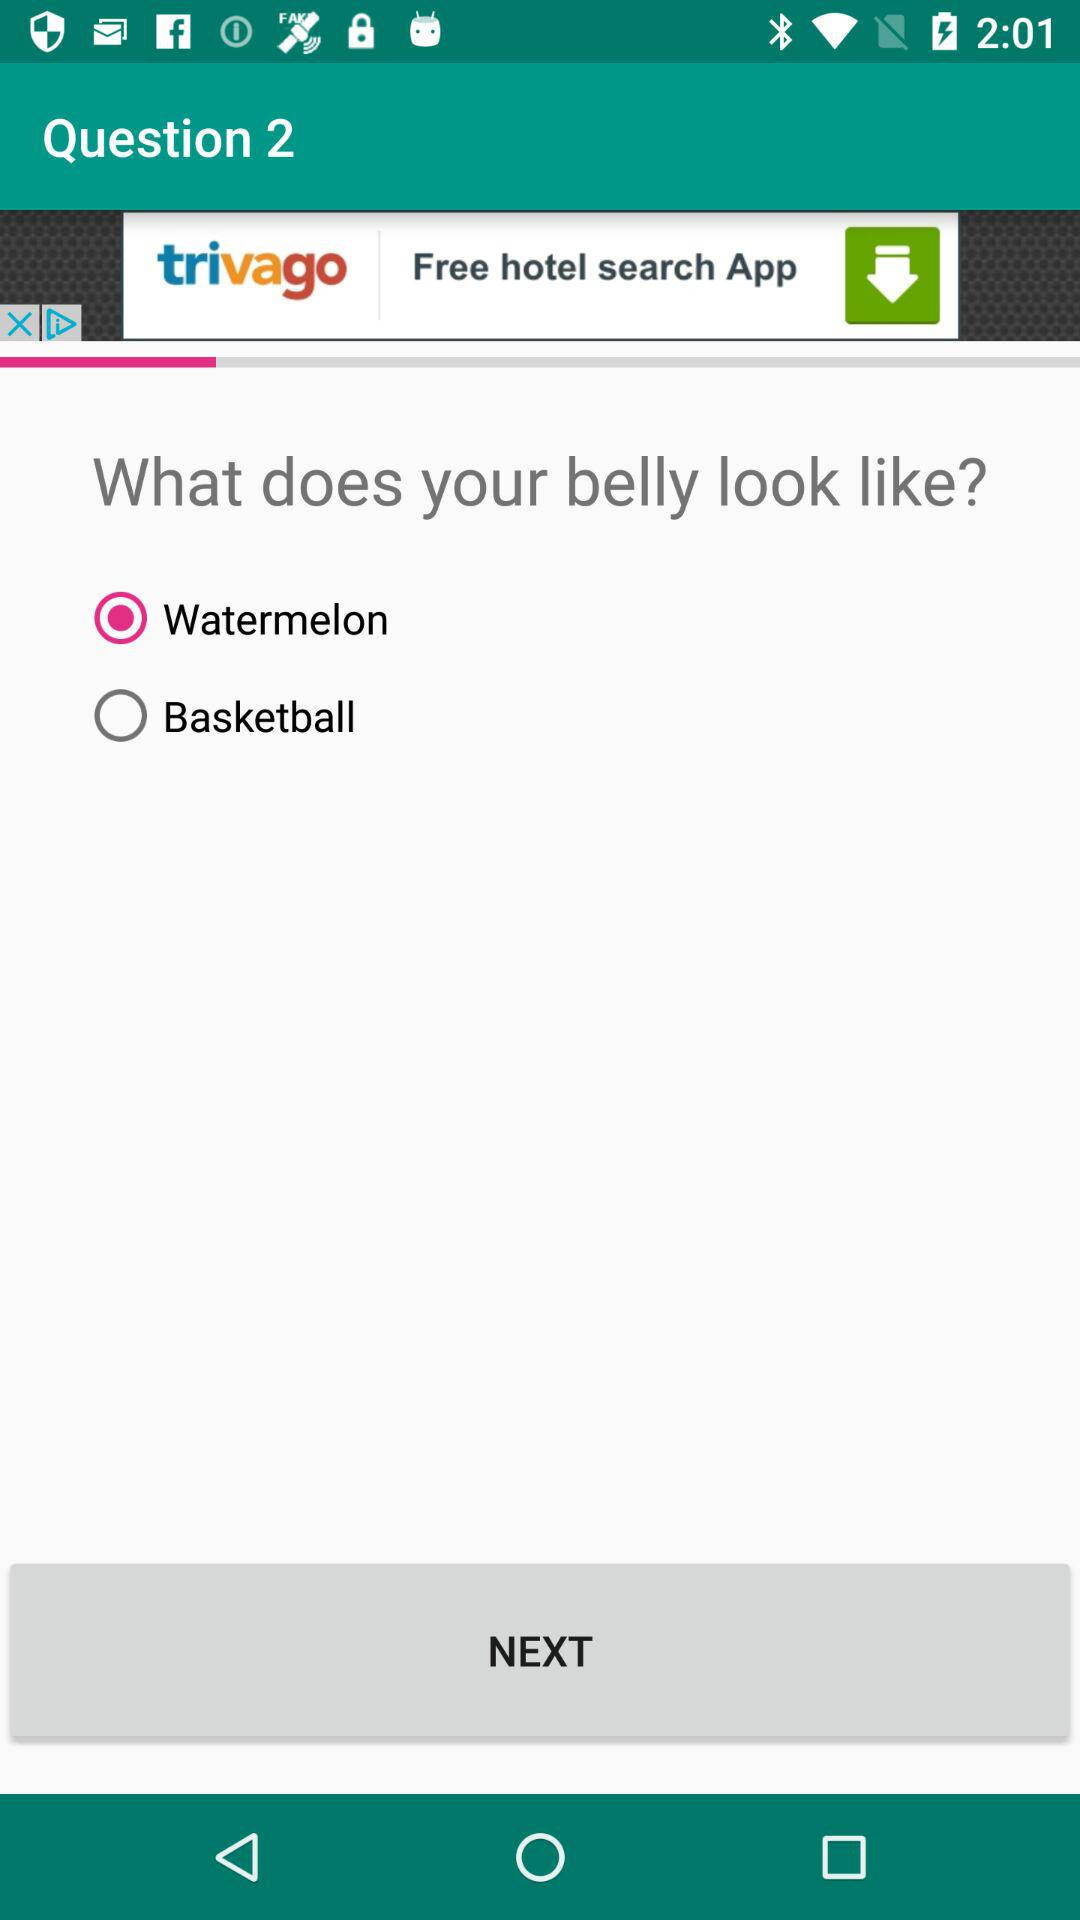What answer has been selected? The selected answer is "Watermelon". 